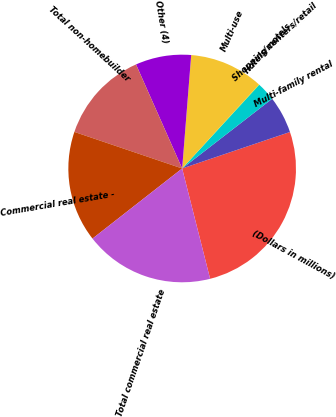<chart> <loc_0><loc_0><loc_500><loc_500><pie_chart><fcel>(Dollars in millions)<fcel>Multi-family rental<fcel>Shopping centers/retail<fcel>Hotels/motels<fcel>Multi-use<fcel>Other (4)<fcel>Total non-homebuilder<fcel>Commercial real estate -<fcel>Total commercial real estate<nl><fcel>26.24%<fcel>5.29%<fcel>2.67%<fcel>0.05%<fcel>10.53%<fcel>7.91%<fcel>13.15%<fcel>15.77%<fcel>18.39%<nl></chart> 